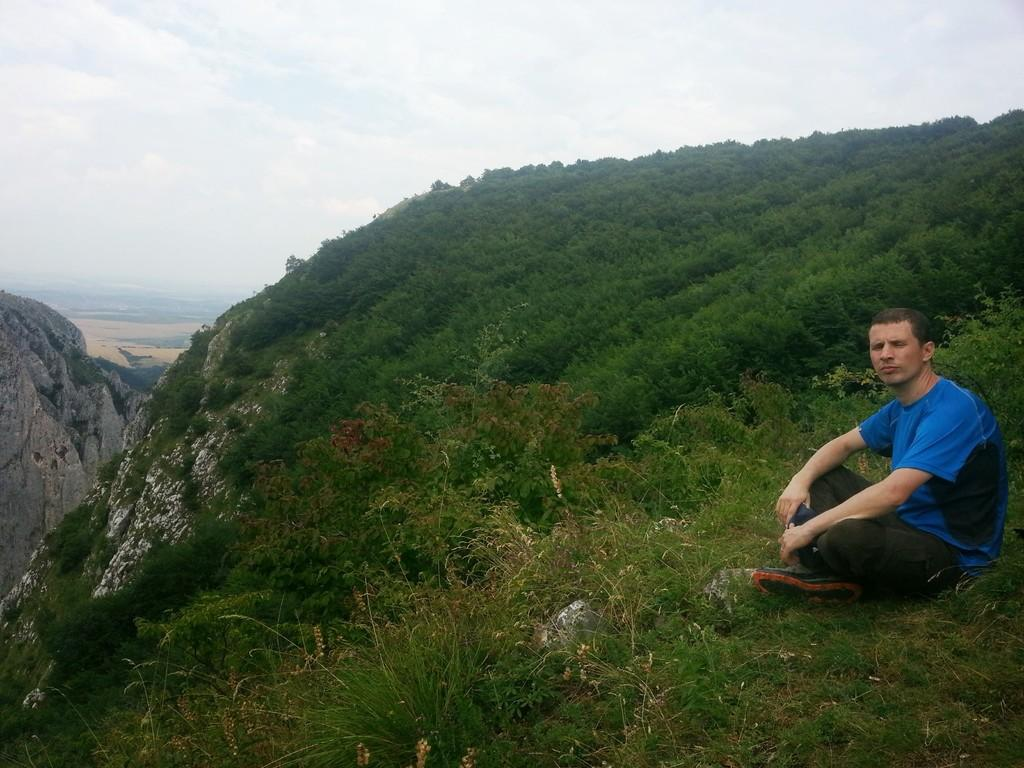What is the man doing in the image? The man is sitting on the ground at the right side of the image. What type of terrain is visible in the center of the image? There is grass in the center of the image. What can be seen in the distance behind the grass? There are mountains in the background of the image. How would you describe the weather based on the sky in the image? The sky is cloudy in the image. What type of ship can be seen sailing along the edge of the grass in the image? There is no ship present in the image; it features a man sitting on the ground, grass, mountains, and a cloudy sky. 